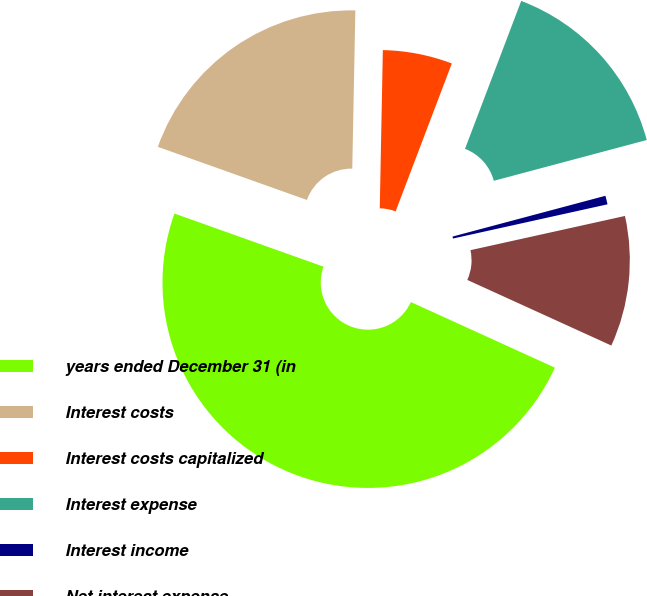<chart> <loc_0><loc_0><loc_500><loc_500><pie_chart><fcel>years ended December 31 (in<fcel>Interest costs<fcel>Interest costs capitalized<fcel>Interest expense<fcel>Interest income<fcel>Net interest expense<nl><fcel>48.64%<fcel>19.86%<fcel>5.47%<fcel>15.07%<fcel>0.68%<fcel>10.27%<nl></chart> 